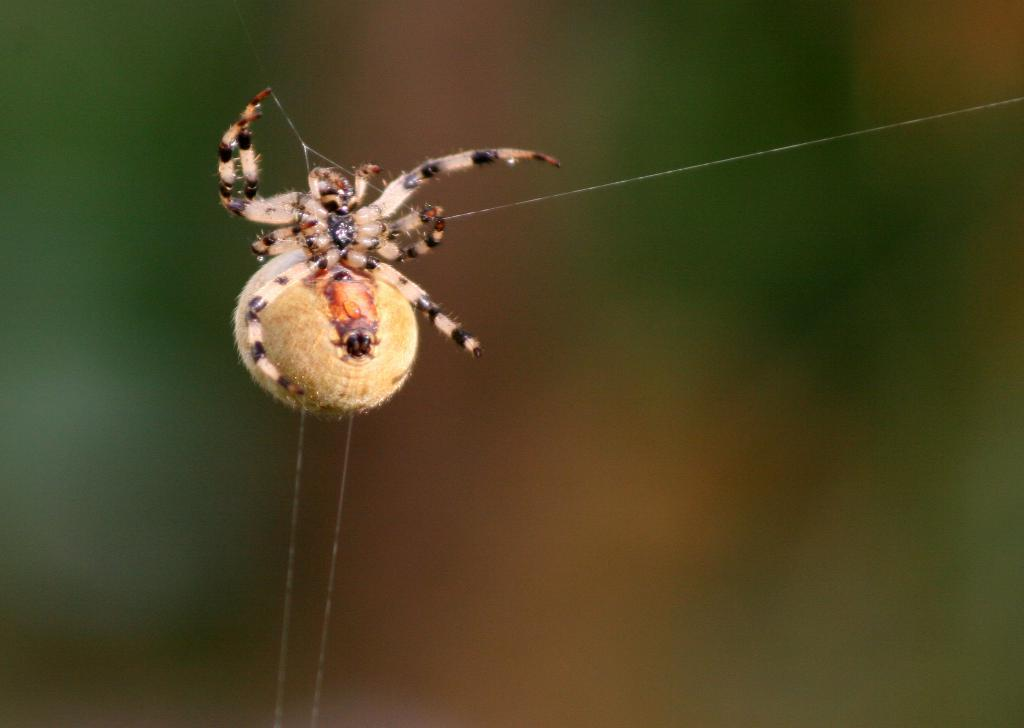What is the main subject of the image? There is a spider in the image. What is associated with the spider in the image? There is a spider web in the image. Can you describe the background of the image? The background of the image is blurry. Who is the actor in the image? There is no actor present in the image; it features a spider and a spider web. Does the owner of the spider appear in the image? There is no owner depicted in the image, only the spider and the spider web. 